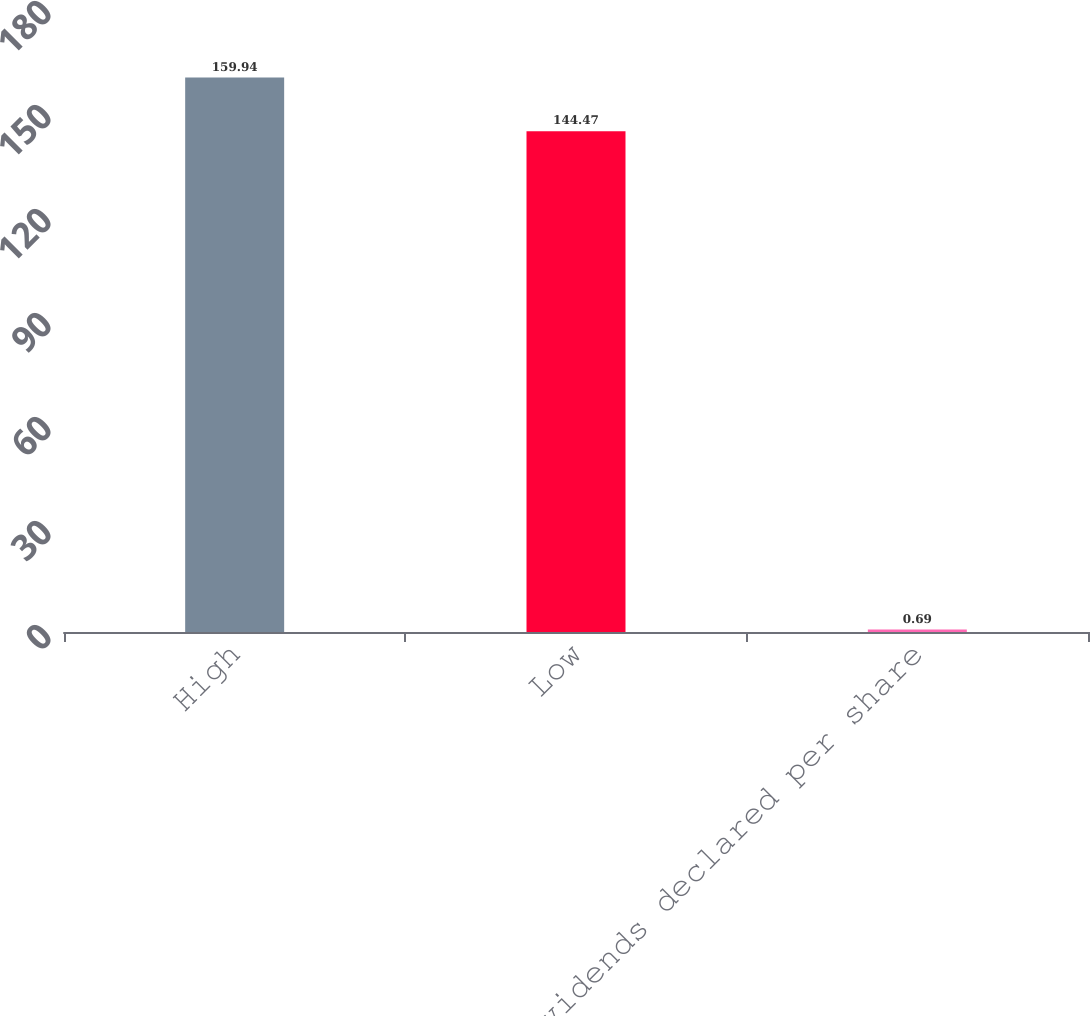Convert chart. <chart><loc_0><loc_0><loc_500><loc_500><bar_chart><fcel>High<fcel>Low<fcel>Dividends declared per share<nl><fcel>159.94<fcel>144.47<fcel>0.69<nl></chart> 